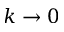Convert formula to latex. <formula><loc_0><loc_0><loc_500><loc_500>k \rightarrow 0</formula> 